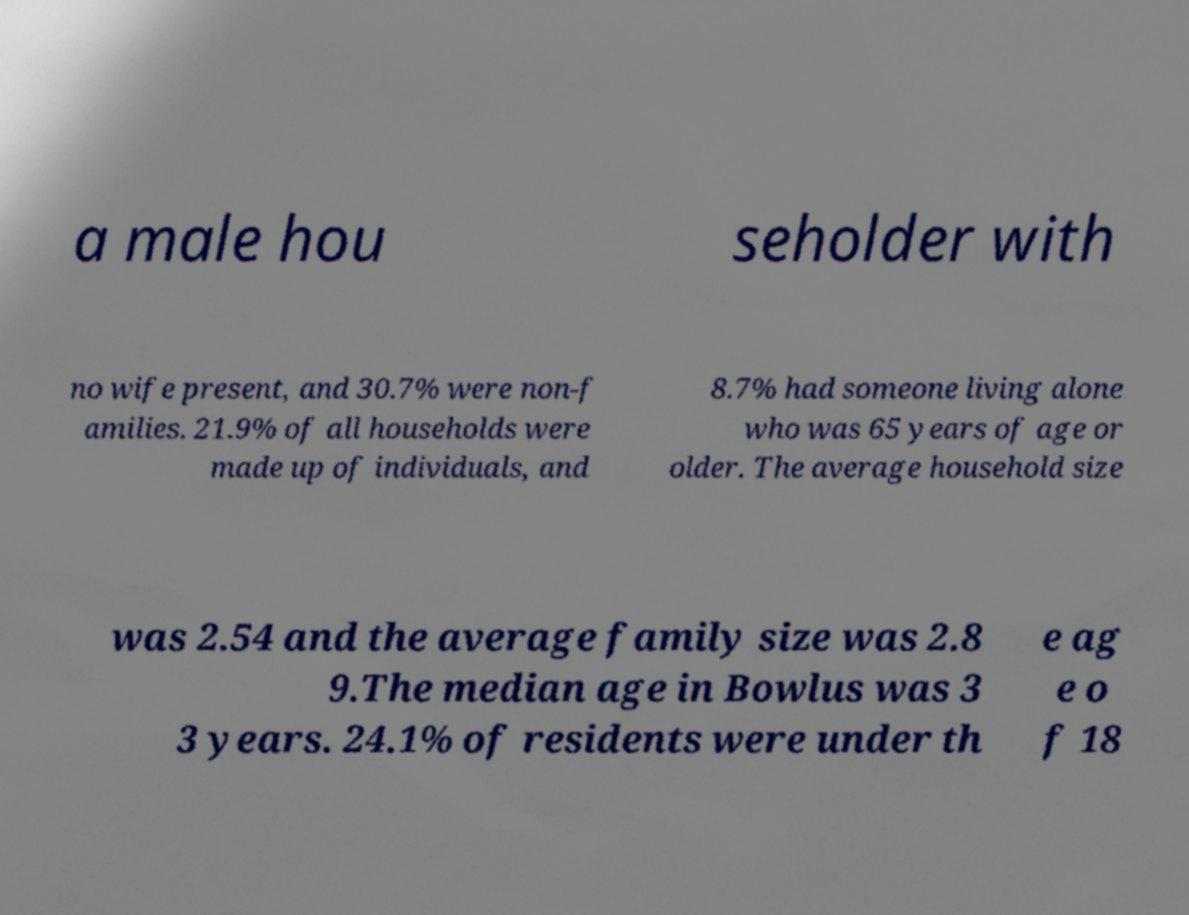Can you accurately transcribe the text from the provided image for me? a male hou seholder with no wife present, and 30.7% were non-f amilies. 21.9% of all households were made up of individuals, and 8.7% had someone living alone who was 65 years of age or older. The average household size was 2.54 and the average family size was 2.8 9.The median age in Bowlus was 3 3 years. 24.1% of residents were under th e ag e o f 18 